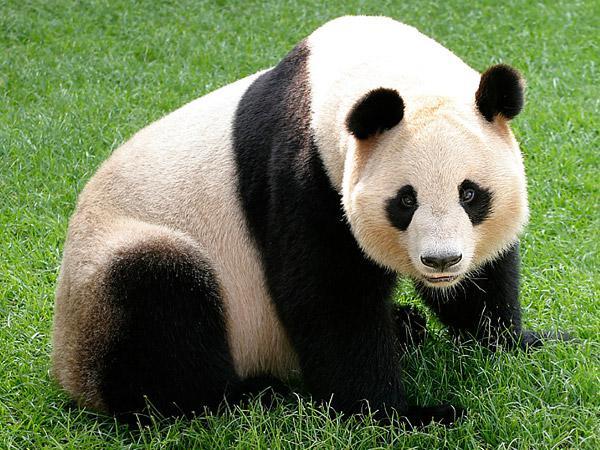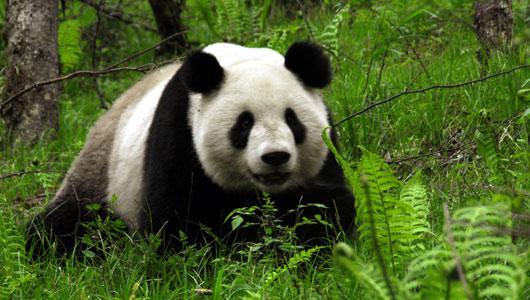The first image is the image on the left, the second image is the image on the right. Assess this claim about the two images: "There is a Panda sitting and eating bamboo.". Correct or not? Answer yes or no. No. The first image is the image on the left, the second image is the image on the right. For the images shown, is this caption "In both image the panda is eating." true? Answer yes or no. No. 